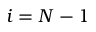Convert formula to latex. <formula><loc_0><loc_0><loc_500><loc_500>i = N - 1</formula> 